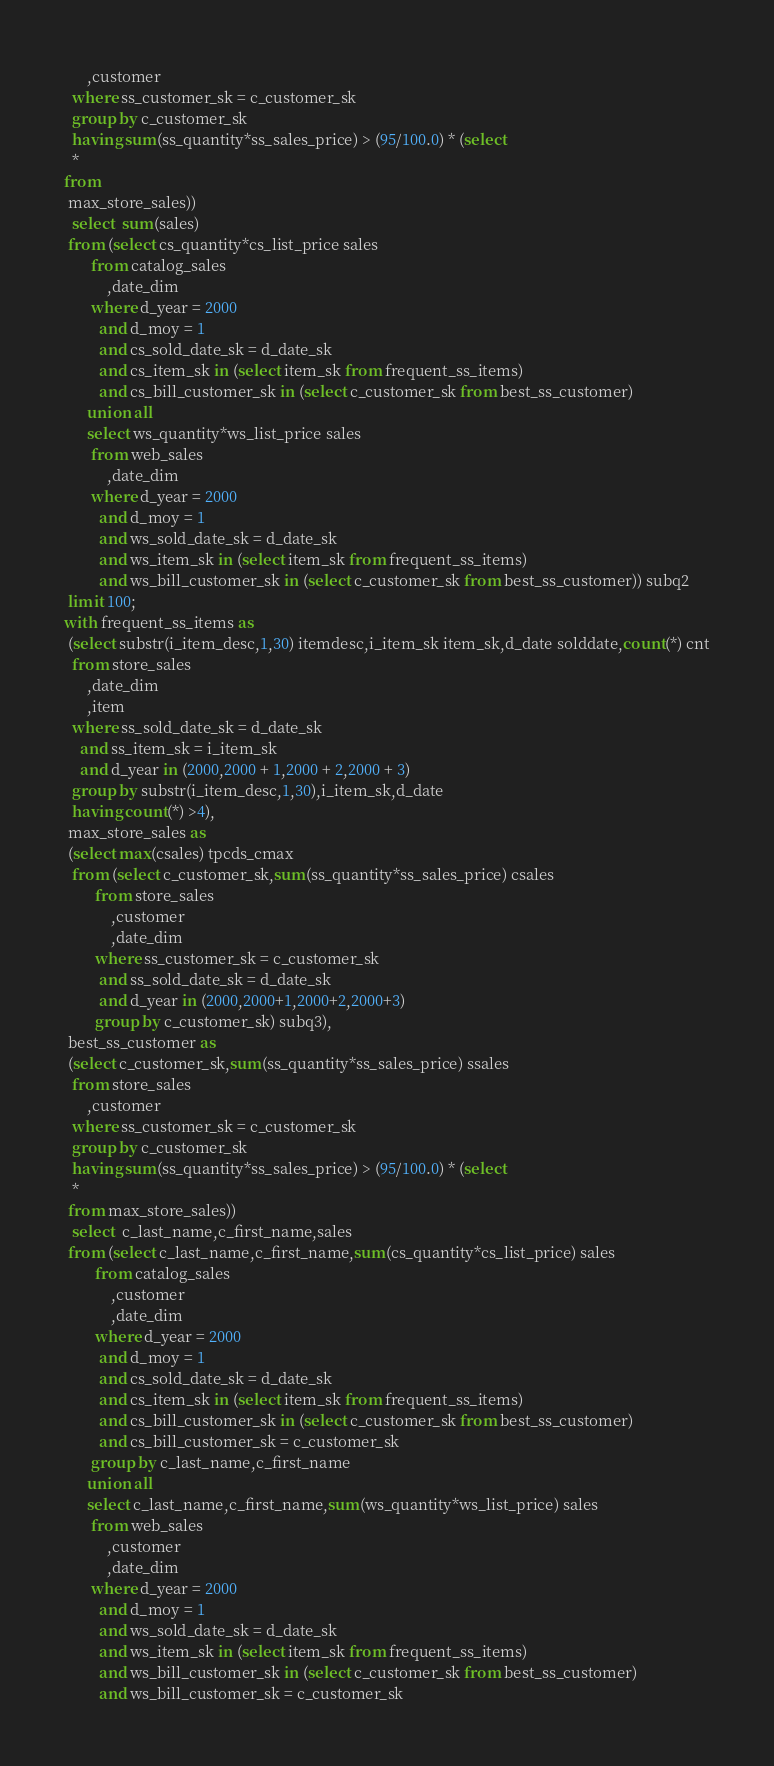<code> <loc_0><loc_0><loc_500><loc_500><_SQL_>      ,customer
  where ss_customer_sk = c_customer_sk
  group by c_customer_sk
  having sum(ss_quantity*ss_sales_price) > (95/100.0) * (select
  *
from
 max_store_sales))
  select  sum(sales)
 from (select cs_quantity*cs_list_price sales
       from catalog_sales
           ,date_dim
       where d_year = 2000
         and d_moy = 1
         and cs_sold_date_sk = d_date_sk
         and cs_item_sk in (select item_sk from frequent_ss_items)
         and cs_bill_customer_sk in (select c_customer_sk from best_ss_customer)
      union all
      select ws_quantity*ws_list_price sales
       from web_sales
           ,date_dim
       where d_year = 2000
         and d_moy = 1
         and ws_sold_date_sk = d_date_sk
         and ws_item_sk in (select item_sk from frequent_ss_items)
         and ws_bill_customer_sk in (select c_customer_sk from best_ss_customer)) subq2
 limit 100;
with frequent_ss_items as
 (select substr(i_item_desc,1,30) itemdesc,i_item_sk item_sk,d_date solddate,count(*) cnt
  from store_sales
      ,date_dim
      ,item
  where ss_sold_date_sk = d_date_sk
    and ss_item_sk = i_item_sk
    and d_year in (2000,2000 + 1,2000 + 2,2000 + 3)
  group by substr(i_item_desc,1,30),i_item_sk,d_date
  having count(*) >4),
 max_store_sales as
 (select max(csales) tpcds_cmax
  from (select c_customer_sk,sum(ss_quantity*ss_sales_price) csales
        from store_sales
            ,customer
            ,date_dim
        where ss_customer_sk = c_customer_sk
         and ss_sold_date_sk = d_date_sk
         and d_year in (2000,2000+1,2000+2,2000+3)
        group by c_customer_sk) subq3),
 best_ss_customer as
 (select c_customer_sk,sum(ss_quantity*ss_sales_price) ssales
  from store_sales
      ,customer
  where ss_customer_sk = c_customer_sk
  group by c_customer_sk
  having sum(ss_quantity*ss_sales_price) > (95/100.0) * (select
  *
 from max_store_sales))
  select  c_last_name,c_first_name,sales
 from (select c_last_name,c_first_name,sum(cs_quantity*cs_list_price) sales
        from catalog_sales
            ,customer
            ,date_dim
        where d_year = 2000
         and d_moy = 1
         and cs_sold_date_sk = d_date_sk
         and cs_item_sk in (select item_sk from frequent_ss_items)
         and cs_bill_customer_sk in (select c_customer_sk from best_ss_customer)
         and cs_bill_customer_sk = c_customer_sk
       group by c_last_name,c_first_name
      union all
      select c_last_name,c_first_name,sum(ws_quantity*ws_list_price) sales
       from web_sales
           ,customer
           ,date_dim
       where d_year = 2000
         and d_moy = 1
         and ws_sold_date_sk = d_date_sk
         and ws_item_sk in (select item_sk from frequent_ss_items)
         and ws_bill_customer_sk in (select c_customer_sk from best_ss_customer)
         and ws_bill_customer_sk = c_customer_sk</code> 